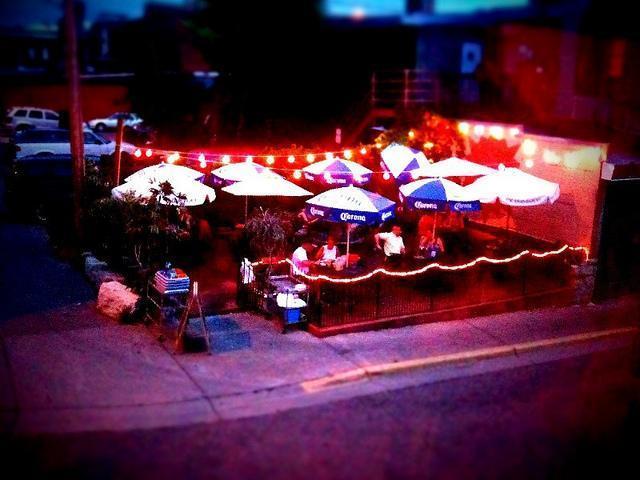How many umbrellas are in this picture?
Give a very brief answer. 10. How many umbrellas can be seen?
Give a very brief answer. 3. 